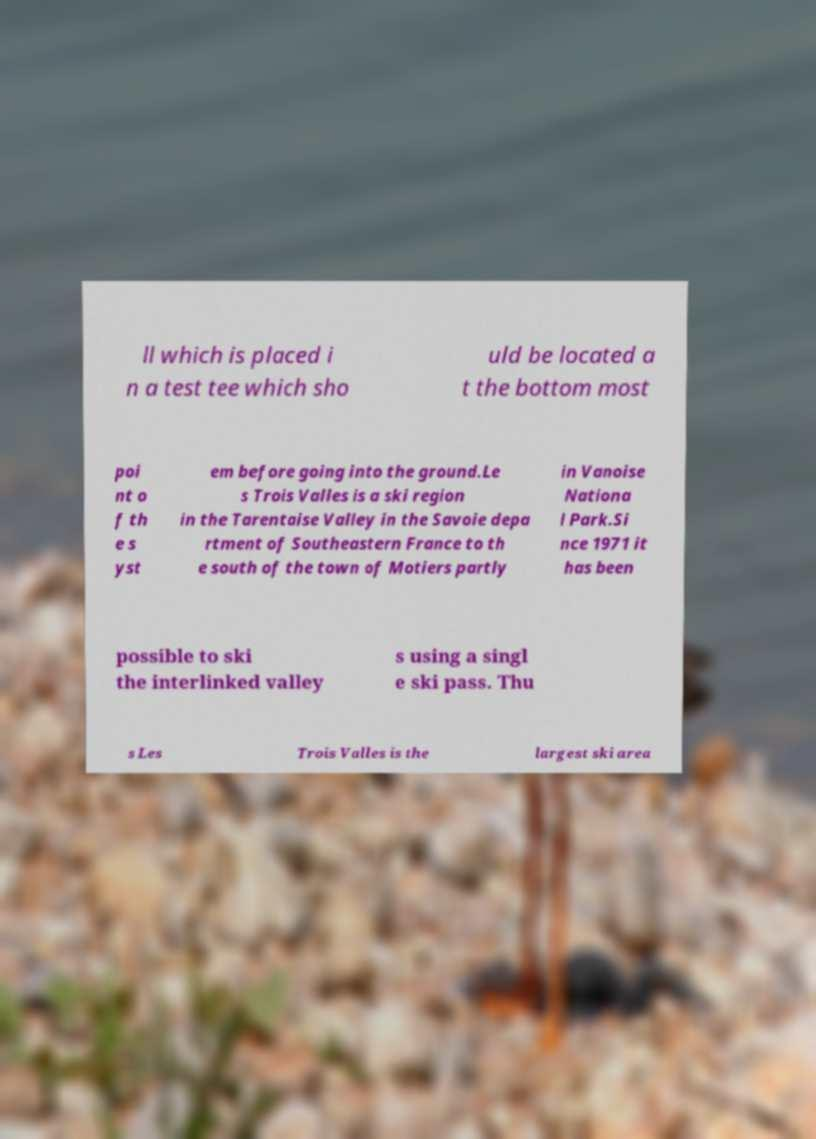Can you accurately transcribe the text from the provided image for me? ll which is placed i n a test tee which sho uld be located a t the bottom most poi nt o f th e s yst em before going into the ground.Le s Trois Valles is a ski region in the Tarentaise Valley in the Savoie depa rtment of Southeastern France to th e south of the town of Motiers partly in Vanoise Nationa l Park.Si nce 1971 it has been possible to ski the interlinked valley s using a singl e ski pass. Thu s Les Trois Valles is the largest ski area 